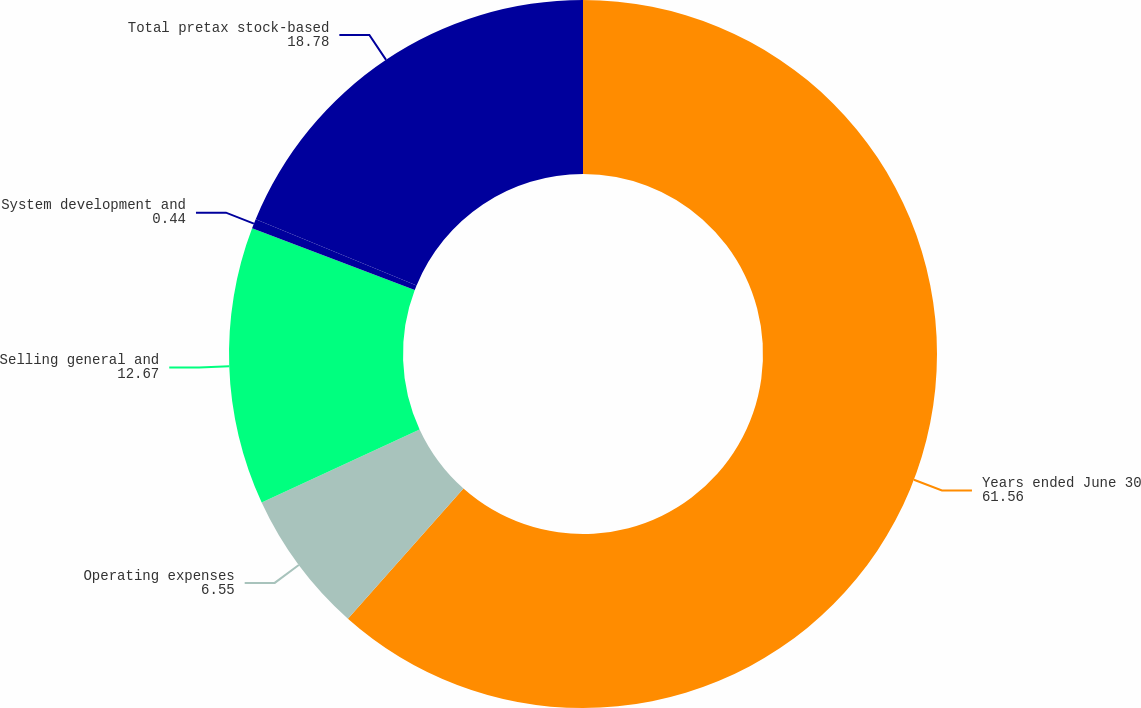Convert chart to OTSL. <chart><loc_0><loc_0><loc_500><loc_500><pie_chart><fcel>Years ended June 30<fcel>Operating expenses<fcel>Selling general and<fcel>System development and<fcel>Total pretax stock-based<nl><fcel>61.56%<fcel>6.55%<fcel>12.67%<fcel>0.44%<fcel>18.78%<nl></chart> 